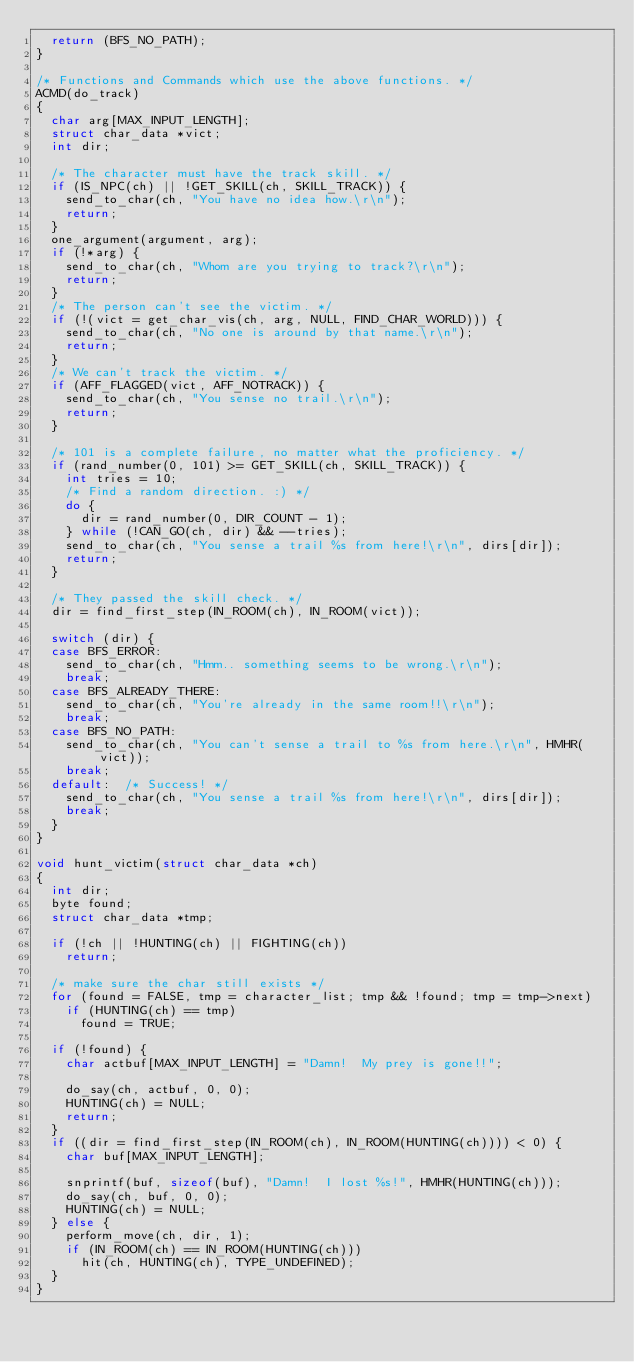<code> <loc_0><loc_0><loc_500><loc_500><_C_>  return (BFS_NO_PATH);
}

/* Functions and Commands which use the above functions. */
ACMD(do_track)
{
  char arg[MAX_INPUT_LENGTH];
  struct char_data *vict;
  int dir;

  /* The character must have the track skill. */
  if (IS_NPC(ch) || !GET_SKILL(ch, SKILL_TRACK)) {
    send_to_char(ch, "You have no idea how.\r\n");
    return;
  }
  one_argument(argument, arg);
  if (!*arg) {
    send_to_char(ch, "Whom are you trying to track?\r\n");
    return;
  }
  /* The person can't see the victim. */
  if (!(vict = get_char_vis(ch, arg, NULL, FIND_CHAR_WORLD))) {
    send_to_char(ch, "No one is around by that name.\r\n");
    return;
  }
  /* We can't track the victim. */
  if (AFF_FLAGGED(vict, AFF_NOTRACK)) {
    send_to_char(ch, "You sense no trail.\r\n");
    return;
  }

  /* 101 is a complete failure, no matter what the proficiency. */
  if (rand_number(0, 101) >= GET_SKILL(ch, SKILL_TRACK)) {
    int tries = 10;
    /* Find a random direction. :) */
    do {
      dir = rand_number(0, DIR_COUNT - 1);
    } while (!CAN_GO(ch, dir) && --tries);
    send_to_char(ch, "You sense a trail %s from here!\r\n", dirs[dir]);
    return;
  }

  /* They passed the skill check. */
  dir = find_first_step(IN_ROOM(ch), IN_ROOM(vict));

  switch (dir) {
  case BFS_ERROR:
    send_to_char(ch, "Hmm.. something seems to be wrong.\r\n");
    break;
  case BFS_ALREADY_THERE:
    send_to_char(ch, "You're already in the same room!!\r\n");
    break;
  case BFS_NO_PATH:
    send_to_char(ch, "You can't sense a trail to %s from here.\r\n", HMHR(vict));
    break;
  default:	/* Success! */
    send_to_char(ch, "You sense a trail %s from here!\r\n", dirs[dir]);
    break;
  }
}

void hunt_victim(struct char_data *ch)
{
  int dir;
  byte found;
  struct char_data *tmp;

  if (!ch || !HUNTING(ch) || FIGHTING(ch))
    return;

  /* make sure the char still exists */
  for (found = FALSE, tmp = character_list; tmp && !found; tmp = tmp->next)
    if (HUNTING(ch) == tmp)
      found = TRUE;

  if (!found) {
    char actbuf[MAX_INPUT_LENGTH] = "Damn!  My prey is gone!!";

    do_say(ch, actbuf, 0, 0);
    HUNTING(ch) = NULL;
    return;
  }
  if ((dir = find_first_step(IN_ROOM(ch), IN_ROOM(HUNTING(ch)))) < 0) {
    char buf[MAX_INPUT_LENGTH];

    snprintf(buf, sizeof(buf), "Damn!  I lost %s!", HMHR(HUNTING(ch)));
    do_say(ch, buf, 0, 0);
    HUNTING(ch) = NULL;
  } else {
    perform_move(ch, dir, 1);
    if (IN_ROOM(ch) == IN_ROOM(HUNTING(ch)))
      hit(ch, HUNTING(ch), TYPE_UNDEFINED);
  }
}
</code> 